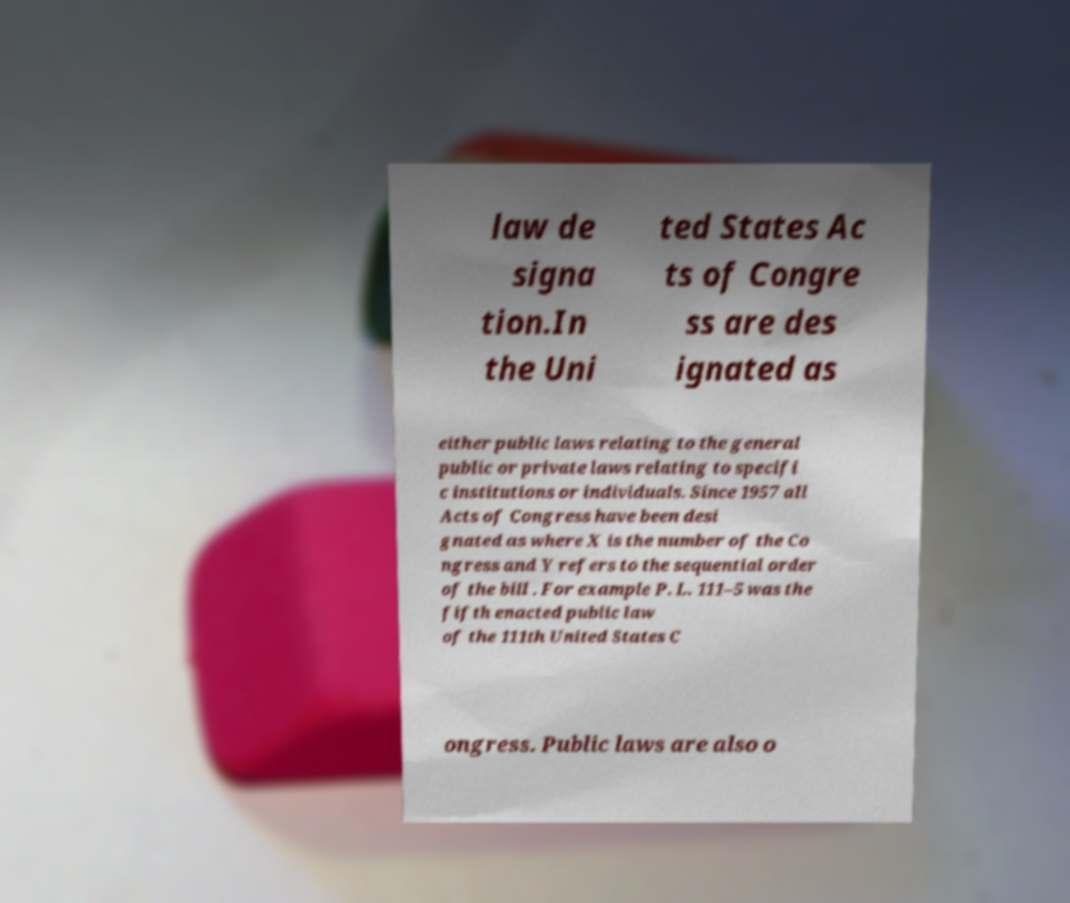Please identify and transcribe the text found in this image. law de signa tion.In the Uni ted States Ac ts of Congre ss are des ignated as either public laws relating to the general public or private laws relating to specifi c institutions or individuals. Since 1957 all Acts of Congress have been desi gnated as where X is the number of the Co ngress and Y refers to the sequential order of the bill . For example P. L. 111–5 was the fifth enacted public law of the 111th United States C ongress. Public laws are also o 